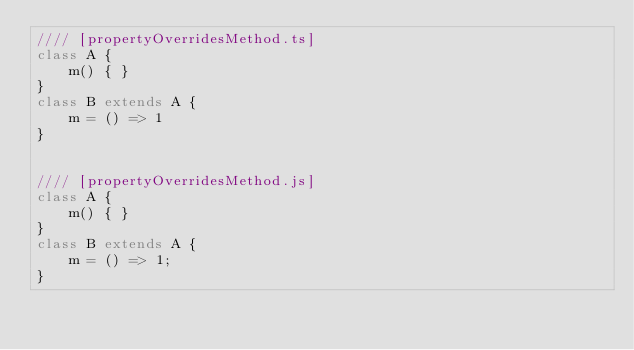Convert code to text. <code><loc_0><loc_0><loc_500><loc_500><_JavaScript_>//// [propertyOverridesMethod.ts]
class A {
    m() { }
}
class B extends A {
    m = () => 1
}


//// [propertyOverridesMethod.js]
class A {
    m() { }
}
class B extends A {
    m = () => 1;
}
</code> 